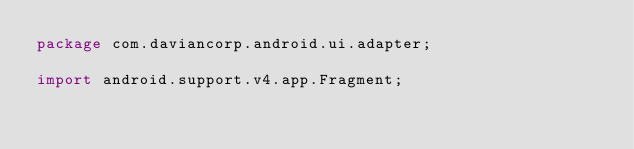<code> <loc_0><loc_0><loc_500><loc_500><_Java_>package com.daviancorp.android.ui.adapter;

import android.support.v4.app.Fragment;</code> 